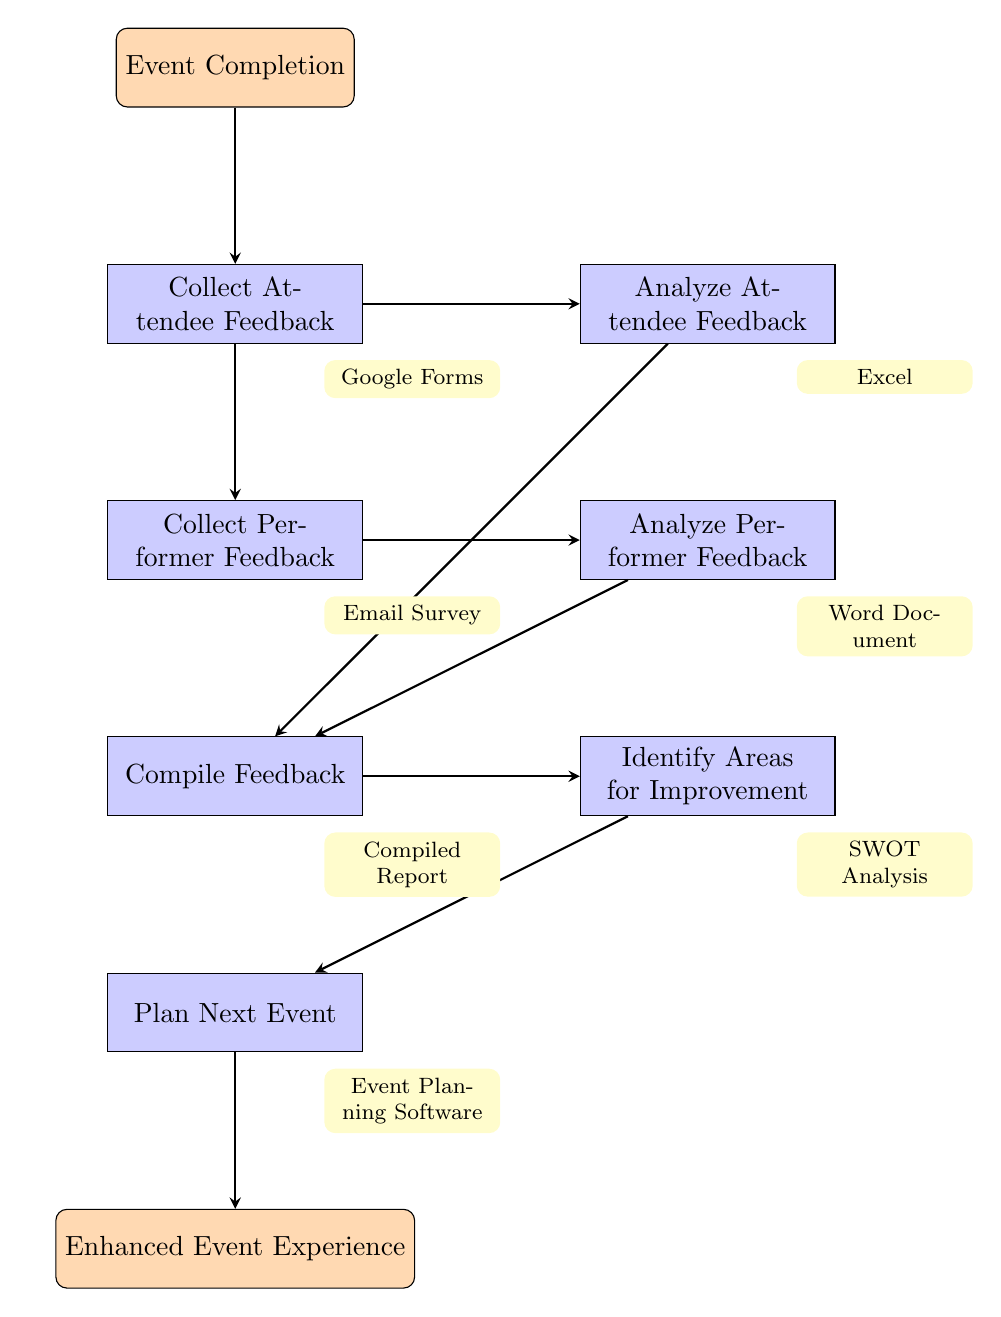What is the first step after event completion? The flow chart indicates that the first step after event completion is to "Collect Attendee Feedback," as it is the first node following the start node.
Answer: Collect Attendee Feedback How many feedback collection steps are in the chart? There are two feedback collection steps in the flow chart: "Collect Attendee Feedback" and "Collect Performer Feedback."
Answer: 2 Which tool is used to analyze attendee feedback? The flowchart specifies that the tool used to analyze attendee feedback is "Excel," as indicated next to the "Analyze Attendee Feedback" node.
Answer: Excel What action follows the analysis of performer feedback? After analyzing performer feedback, the next action in the flow chart is to "Compile Feedback," which is the subsequent node connected by an arrow.
Answer: Compile Feedback What is produced after integrating attendee and performer feedback? The flow chart indicates that the integration of attendee and performer feedback produces a "Compiled Report," as noted in the corresponding node.
Answer: Compiled Report What are the last two steps in the flow chart? Upon reviewing the flow chart, the last two steps are "Identify Areas for Improvement" and "Plan Next Event," which are the final two nodes before reaching the end node.
Answer: Identify Areas for Improvement and Plan Next Event Which analysis tool is mentioned for identifying areas for improvement? The flow chart specifies that "SWOT Analysis" is the tool mentioned for identifying areas for improvement, as indicated next to that specific node.
Answer: SWOT Analysis How is feedback implemented into the next event? The flow chart describes that feedback is implemented into the next event through the action "Implement Feedback into Next Event Planning," which directly follows the identification of areas for improvement.
Answer: Implement Feedback into Next Event Planning 